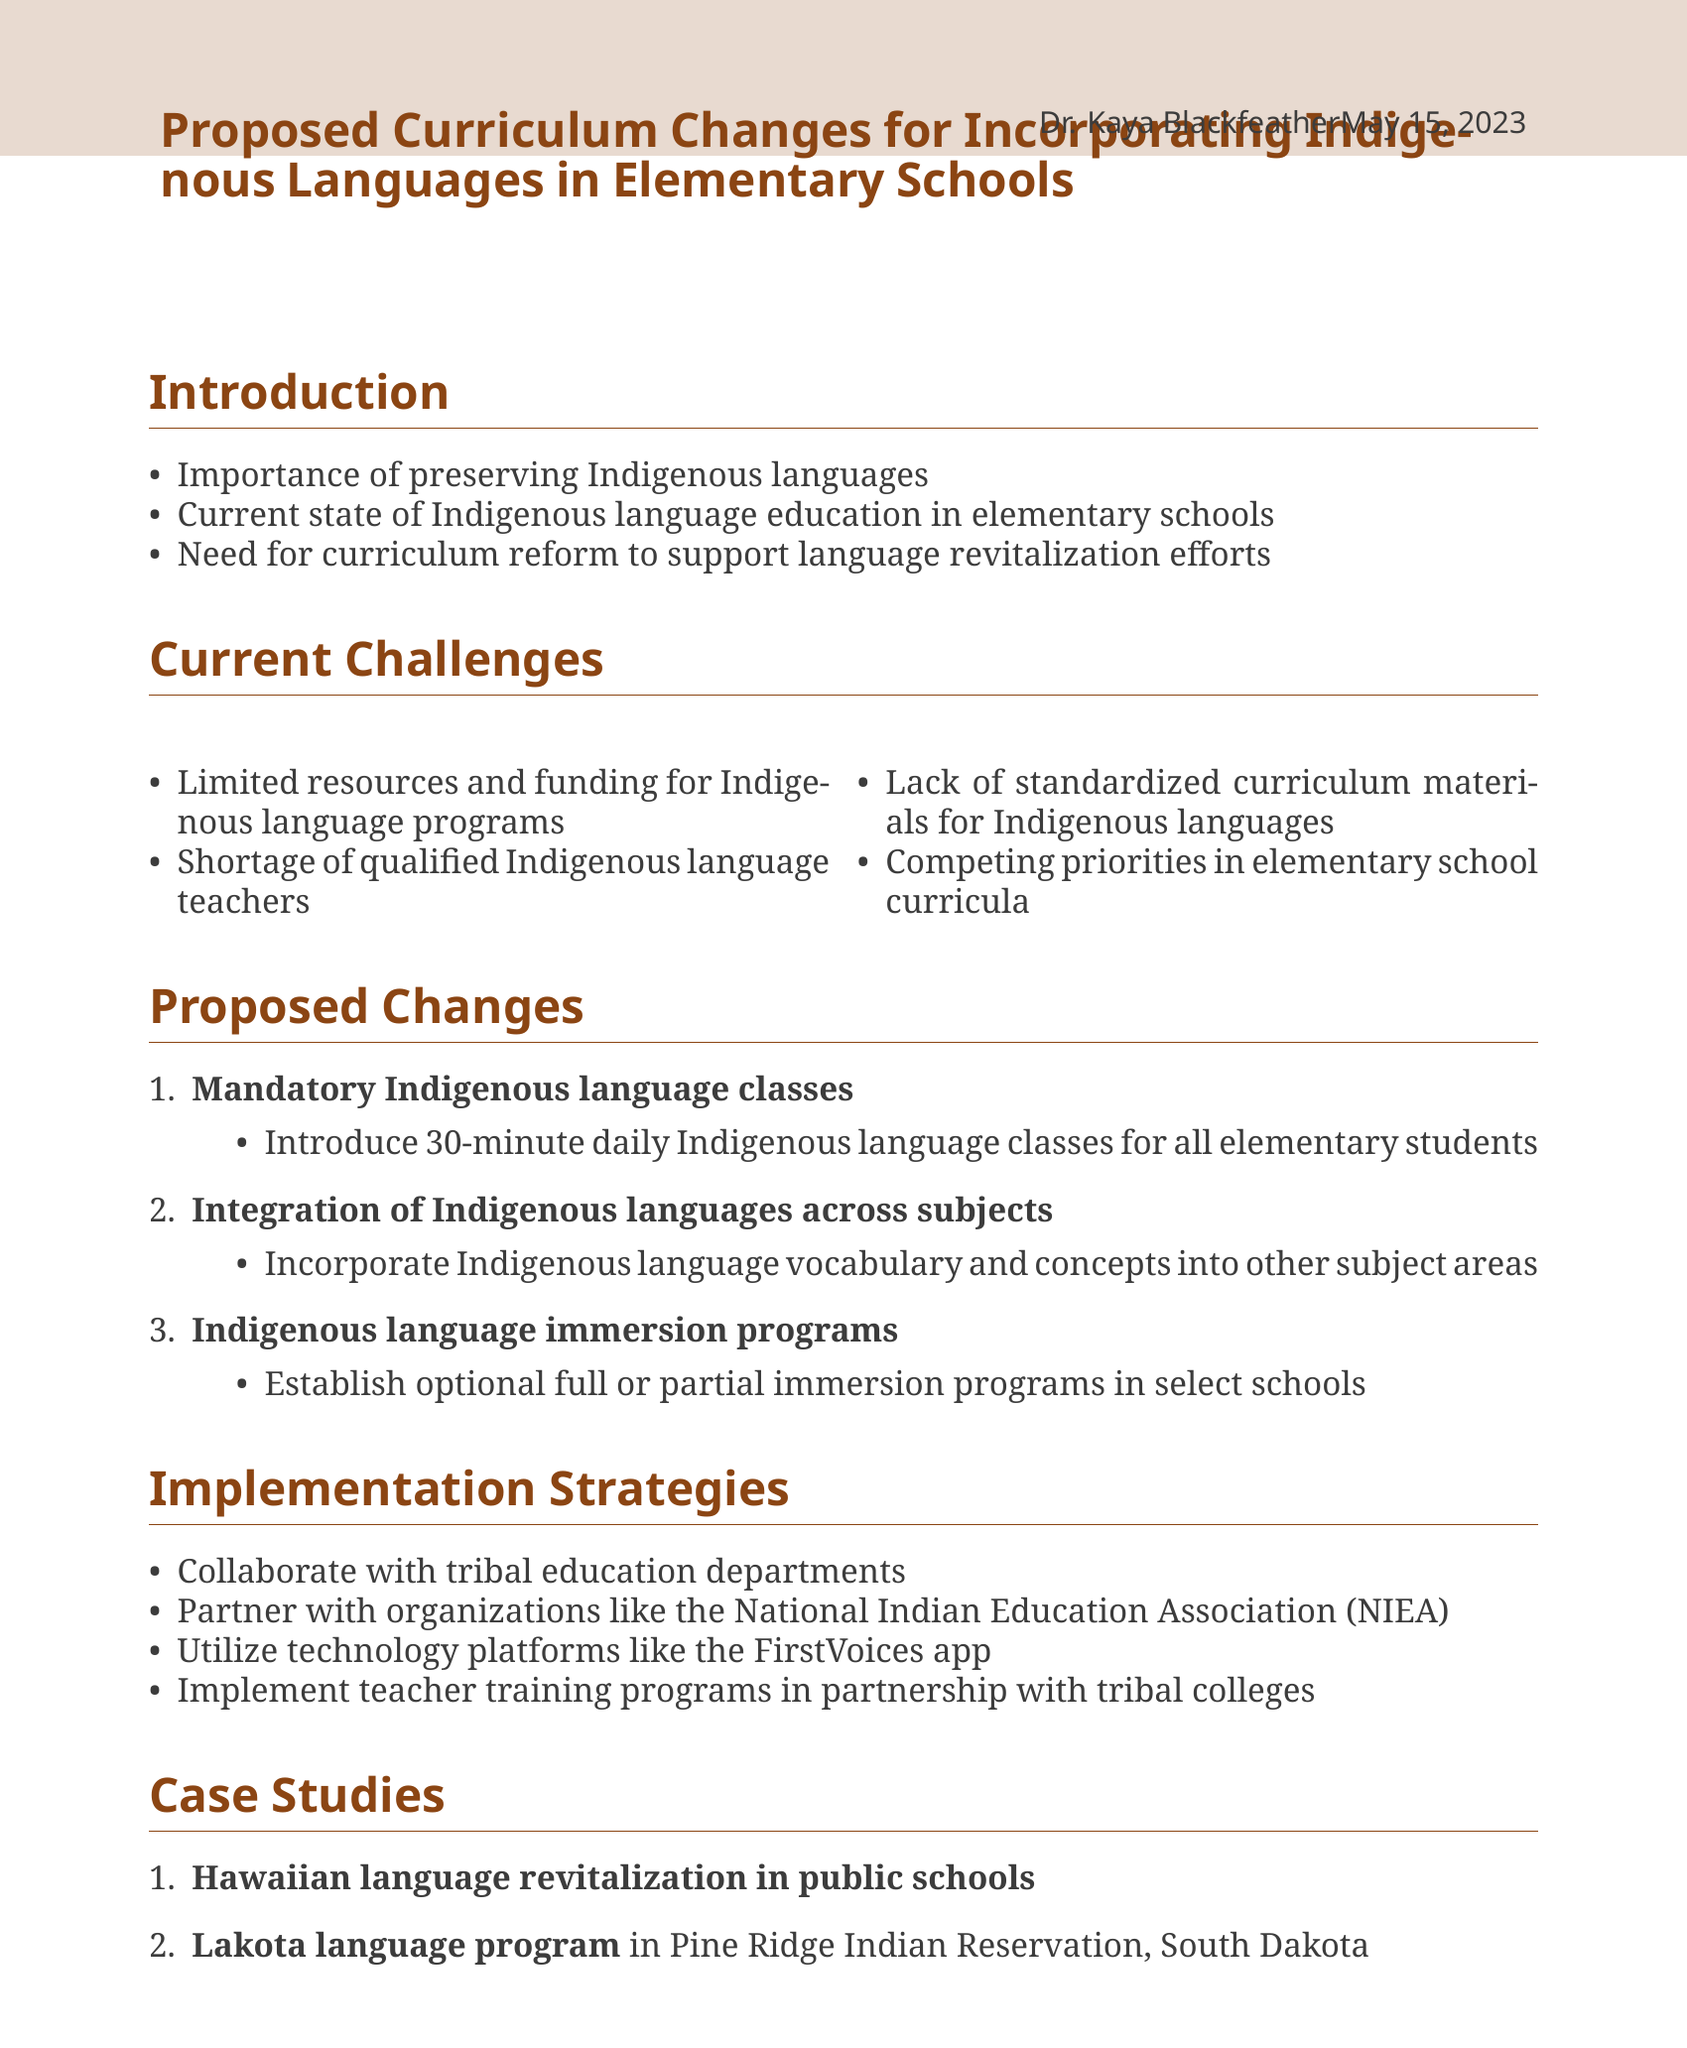What is the title of the memo? The title of the memo is the main focus of the document, summarizing its purpose regarding Indigenous languages in education.
Answer: Proposed Curriculum Changes for Incorporating Indigenous Languages in Elementary Schools Who is the author of the memo? The author's name is provided in the document, which can indicate their qualifications or authority on the subject.
Answer: Dr. Kaya Blackfeather What is one current challenge for Indigenous language education? The document outlines several challenges, highlighting issues that need addressing in language education.
Answer: Limited resources and funding for Indigenous language programs How long should mandatory Indigenous language classes be? The memo specifies the duration of the proposed classes, indicating the seriousness of the initiative.
Answer: 30-minute daily What is a benefit of Indigenous language immersion programs? The memo lists multiple benefits of this educational strategy, suggesting its effectiveness in language learning.
Answer: Creates fluent speakers Which department should schools collaborate with for implementation? The collaboration with established educational departments is essential for the success of the proposed curriculum changes.
Answer: Tribal education departments What does the memo urge educational stakeholders to do? The conclusion points emphasize the urgency and the call to action directed at relevant stakeholders involved in education.
Answer: Immediate action and support Name a case study mentioned in the document. An example from the document illustrates successful implementation of Indigenous language education, showcasing potential outcomes.
Answer: Hawaiian language revitalization in public schools What funding source is listed for supporting Indigenous language programs? Funding sources are crucial for the viability of curriculum changes, and the memo specifies various options available.
Answer: Administration for Native Americans (ANA) Language Preservation Grants 